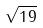Convert formula to latex. <formula><loc_0><loc_0><loc_500><loc_500>\sqrt { 1 9 }</formula> 